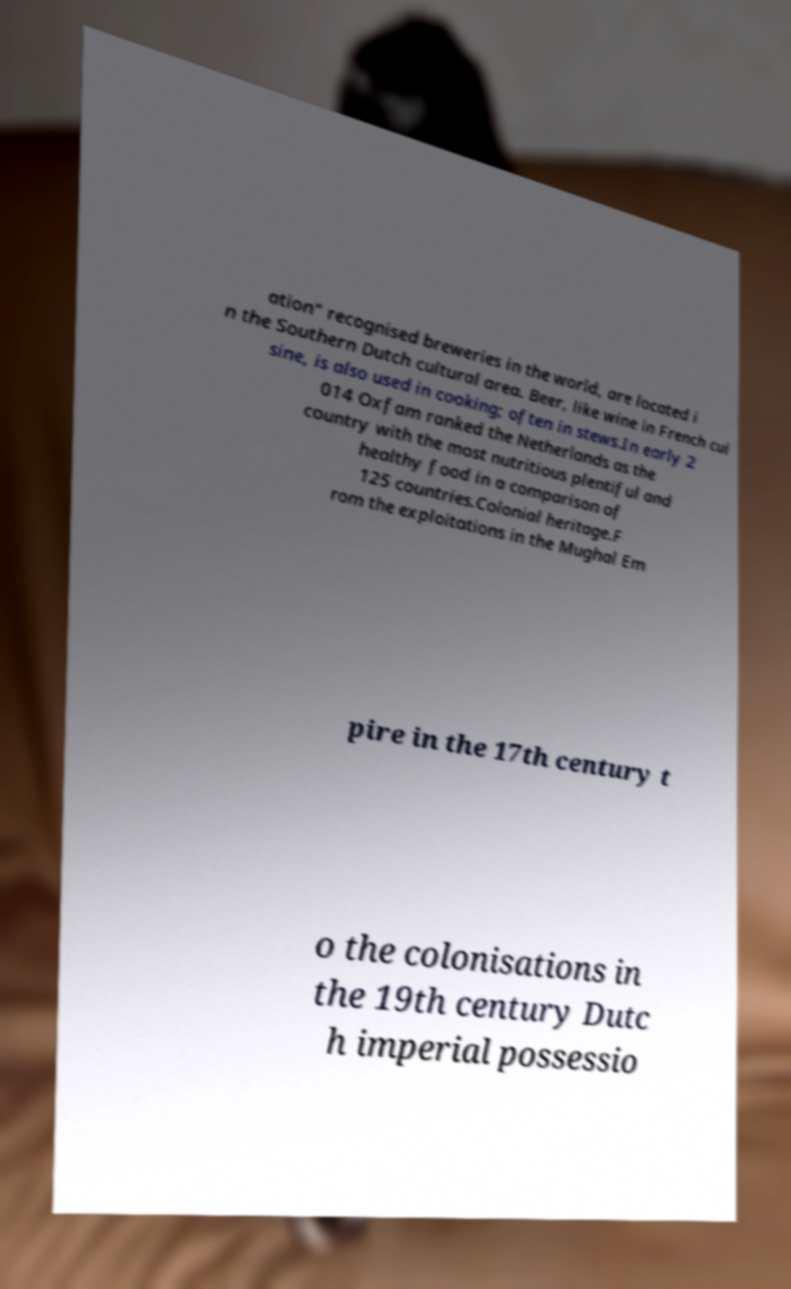Could you assist in decoding the text presented in this image and type it out clearly? ation" recognised breweries in the world, are located i n the Southern Dutch cultural area. Beer, like wine in French cui sine, is also used in cooking; often in stews.In early 2 014 Oxfam ranked the Netherlands as the country with the most nutritious plentiful and healthy food in a comparison of 125 countries.Colonial heritage.F rom the exploitations in the Mughal Em pire in the 17th century t o the colonisations in the 19th century Dutc h imperial possessio 